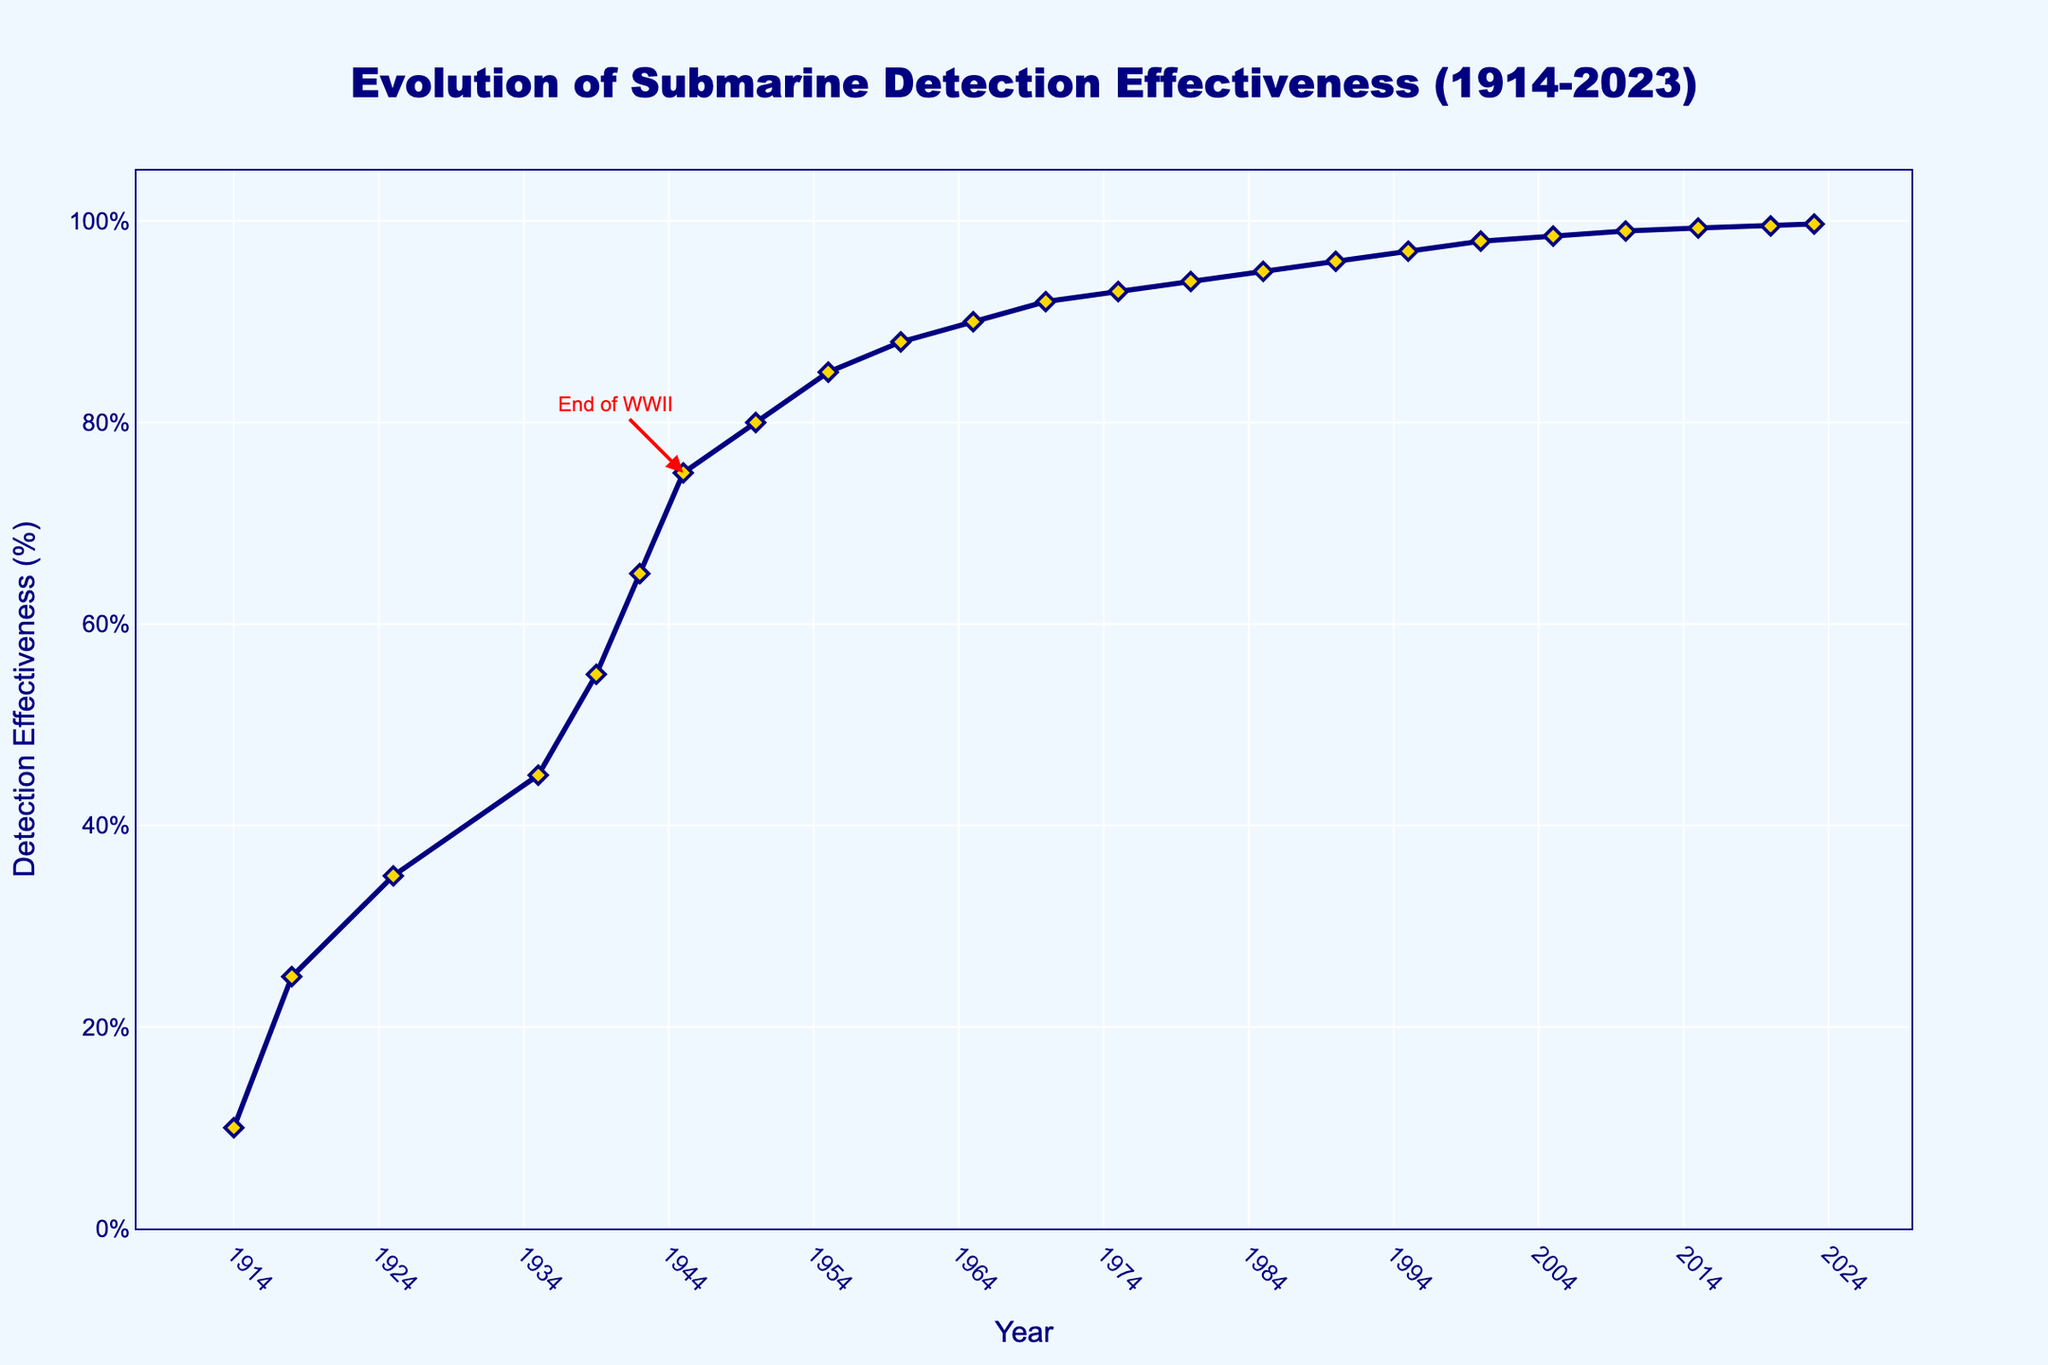What year saw the biggest single increase in submarine detection effectiveness? Referring to the line chart, the jump from 1918 to 1925 shows an increase from 25% to 35%, which is a 10% increase. No other consecutive years show a greater increase.
Answer: 1925 What is the approximate average submarine detection effectiveness from 1914 to 1955? Sum of detection effectiveness from 1914 to 1955 (10 + 25 + 35 + 45 + 55 + 65 + 75 + 80 + 85) = 475. The number of data points in this range is 9, so the average is 475 / 9 ≈ 52.78
Answer: 52.78 By how much did detection effectiveness increase during World War II (1939 to 1945)? In 1939, the detection effectiveness was 55%. By 1945, it had increased to 75%. The increase is 75% - 55% = 20%.
Answer: 20% Was there ever a time when submarine detection effectiveness did not improve for consecutive decades? From 2000 to 2005, the effectiveness was 98% and then 98.5%, showing improvement every decade or a short period.
Answer: No Which decade saw the highest linear growth in submarine detection effectiveness? From 1939 to 1949 (1939: 55% to 1949: 80%), which equals 25% increase over ten years.
Answer: 1939-1949 At what year did the submarine detection effectiveness reach 90% for the first time? By referring to the chart, the effectiveness first reached 90% in 1965.
Answer: 1965 Compare the effectiveness values between the end of World War I and World War II, and state the difference. At the end of World War I (1918), it was 25%, and at the end of World War II (1945), it was 75%. The difference is 75% - 25% = 50%.
Answer: 50% What color is used to represent the line and markers on the chart? The line is depicted in navy color, and the markers are depicted in gold with navy outlines.
Answer: Navy and gold How many annotations are present in the chart and what significant event is marked? There is one annotation present in the chart, marking the "End of WWII" in 1945.
Answer: One Calculate the percentage increase in submarine detection effectiveness from 1914 to 2023. Starting value in 1914 was 10% and increased to 99.7% in 2023. Percentage increase is ((99.7 - 10) / 10) * 100 = 897%.
Answer: 897% 